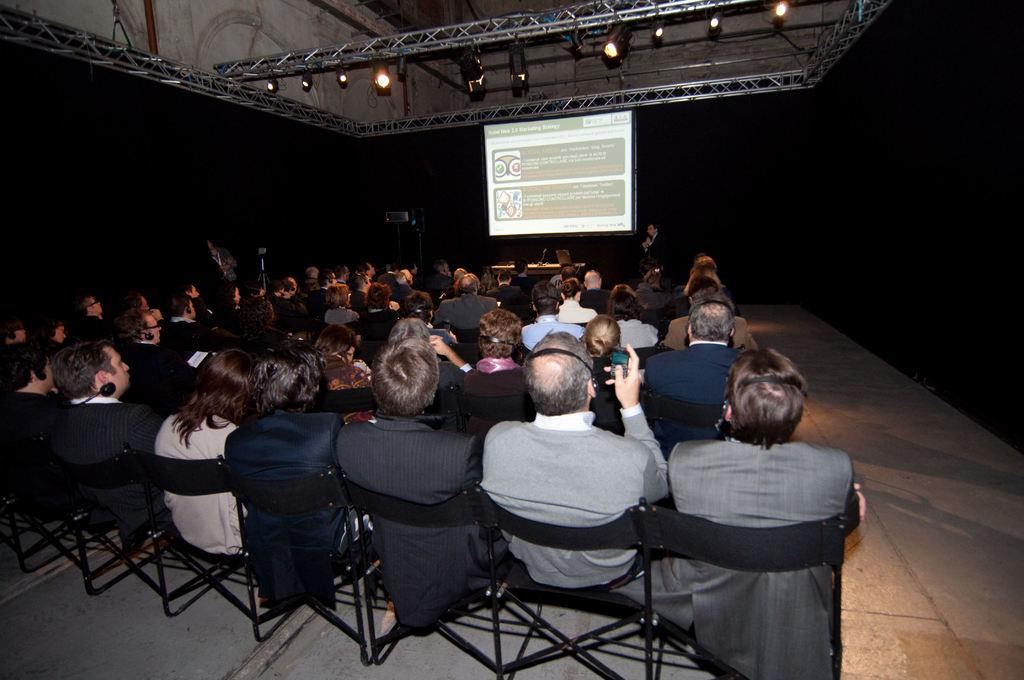How many people are in the image? There is a group of people in the image. What are the people doing in the image? The people are sitting on chairs. What is in front of the people? There is a screen in front of the people. What type of quilt is being used as a reward for the people in the image? There is no quilt or reward present in the image; it only features a group of people sitting on chairs with a screen in front of them. 